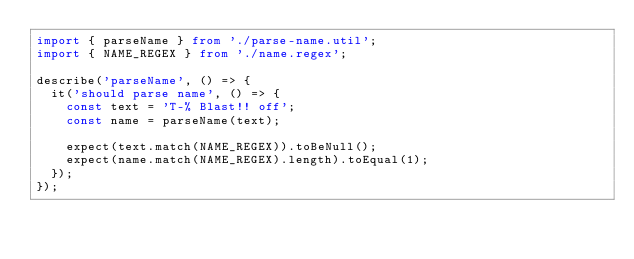<code> <loc_0><loc_0><loc_500><loc_500><_TypeScript_>import { parseName } from './parse-name.util';
import { NAME_REGEX } from './name.regex';

describe('parseName', () => {
  it('should parse name', () => {
    const text = 'T-% Blast!! off';
    const name = parseName(text);

    expect(text.match(NAME_REGEX)).toBeNull();
    expect(name.match(NAME_REGEX).length).toEqual(1);
  });
});
</code> 